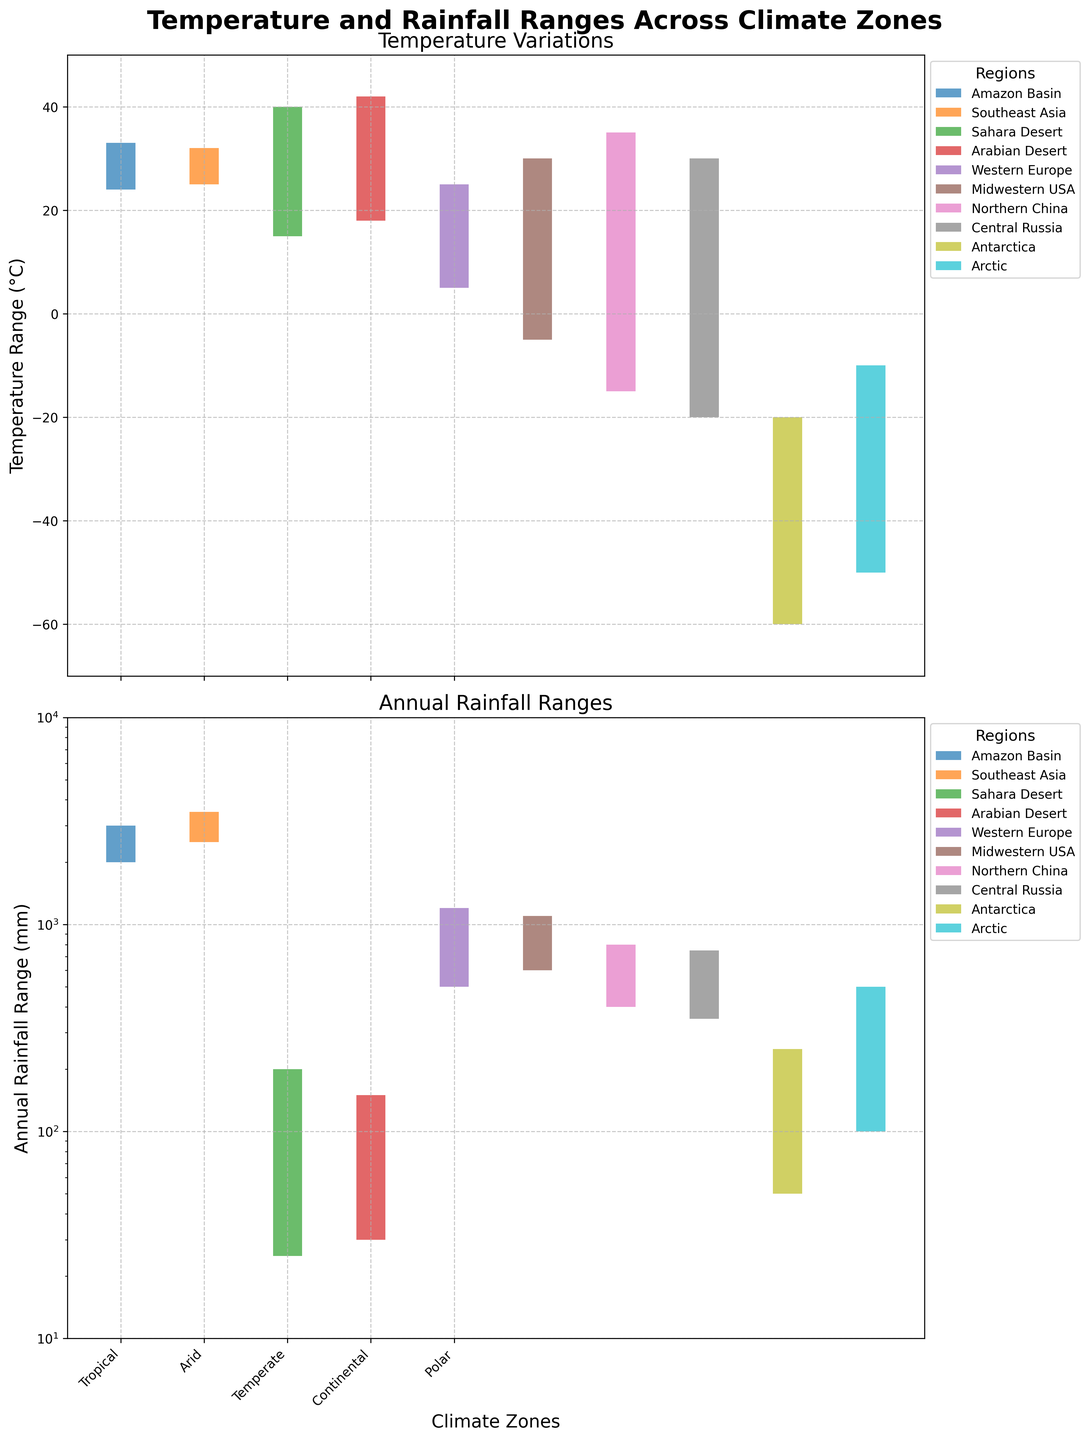What is the title of the figure? The title can be found at the top of the chart. It reads "Temperature and Rainfall Ranges Across Climate Zones".
Answer: Temperature and Rainfall Ranges Across Climate Zones What are the temperature ranges for the Tropical climate zone? Locate the "Tropical" climate zone on the x-axis of the top chart. Notice the ranges for the Amazon Basin and Southeast Asia regions.
Answer: Amazon Basin: 24-33°C, Southeast Asia: 25-32°C Which region has the highest maximum temperature, and what is it? Look at the top chart and identify which region has the maximum temperature at the highest point. The Arabian Desert in the Arid climate zone shows the highest maximum temperature.
Answer: Arabian Desert, 42°C Compare the minimum annual rainfall ranges of the Polar climate zone regions. Which has less minimum annual rainfall? Examine the bottom chart for the Polar climate zone. Compare the regions Antarctica and Arctic; Antarctica has 50 mm, and Arctic has 100 mm. Therefore, Antarctica has less minimum annual rainfall.
Answer: Antarctica What is the difference in the maximum temperature between the Sahara Desert and Western Europe? Identify the maximum temperatures for the Sahara Desert (40°C) and Western Europe (25°C) on the top chart and calculate the difference.
Answer: 15°C Which climate zone exhibits the largest range in annual rainfall, and what are the values? Look at the bottom chart to identify the climate zone with the widest spread in annual rainfall values. The Tropical climate zone shows the largest range with Southeast Asia ranging from 2500 mm to 3500 mm.
Answer: Tropical, 2500-3500 mm How does the minimum temperature for the Midwestern USA compare to Western Europe? Locate the minimum temperatures for both regions on the top chart and compare them. The Midwestern USA has -5°C and Western Europe has 5°C.
Answer: Midwestern USA is 10°C colder What is the temperature range for the Arctic region? Refer to the top chart under the Polar climate zone and identify the temperature range for the Arctic region, which is from -50°C to -10°C.
Answer: -50°C to -10°C Which region within the Continental climate zone has a lower minimum temperature, Northern China or Central Russia? In the top chart, compare the minimum temperatures of Northern China (-15°C) and Central Russia (-20°C). Central Russia’s minimum temperature is lower.
Answer: Central Russia What are the rainfall characteristics of the Amazon Basin region? Look at the bottom chart, in the Tropical climate zone for the Amazon Basin region. The annual rainfall ranges from 2000 mm to 3000 mm.
Answer: 2000-3000 mm 